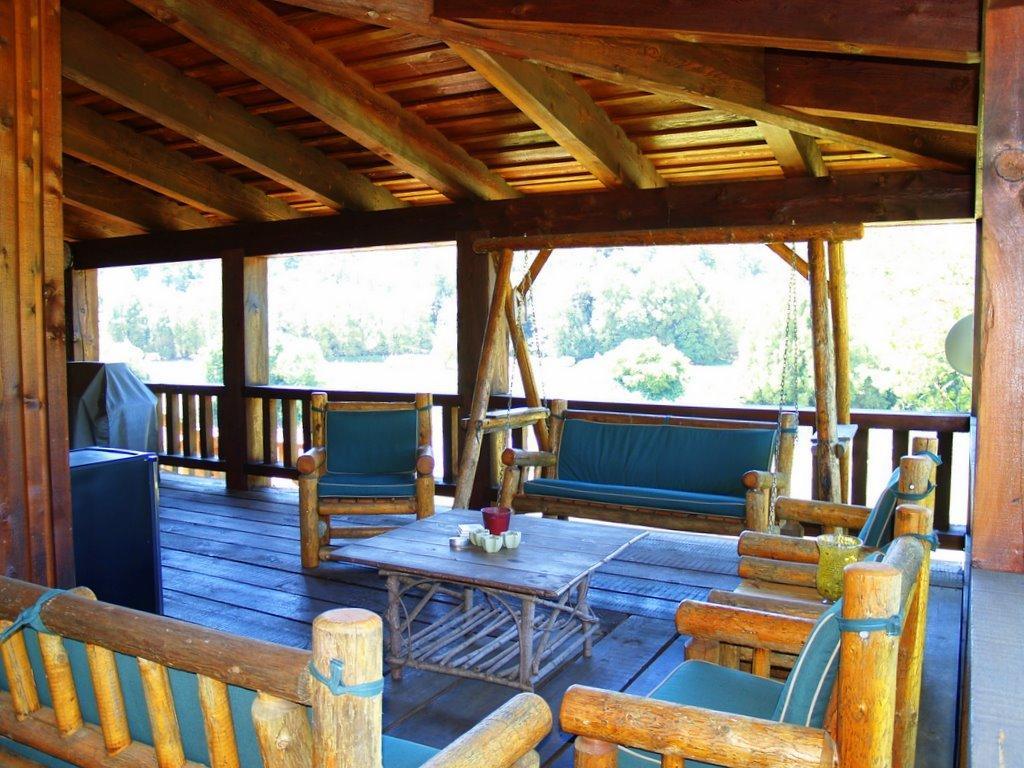Describe this image in one or two sentences. In the foreground of this image, there are wooden chairs, sofas, table on which, there are few objects and also few objects on the floor. At the top, there is roof. In the background, there are trees. We can also see a swing on the floor. 